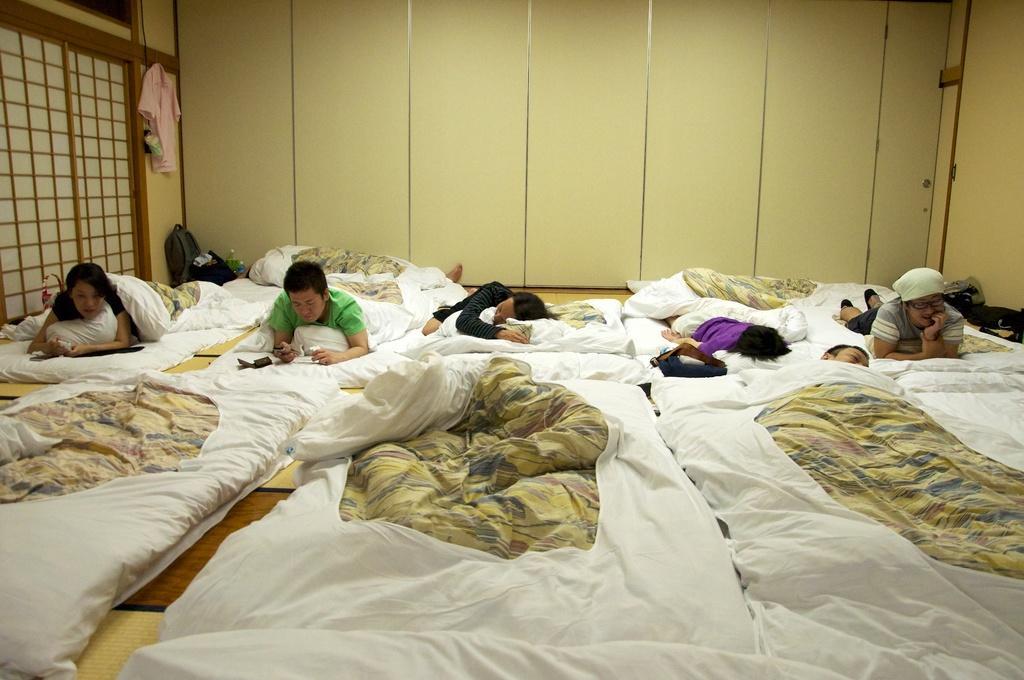Describe this image in one or two sentences. This image is clicked inside a room. There are beds and blankets. People are lying on beds. There is a dress on the left side. There are bags and water bottles on the left side. 